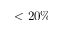Convert formula to latex. <formula><loc_0><loc_0><loc_500><loc_500>< 2 0 \%</formula> 